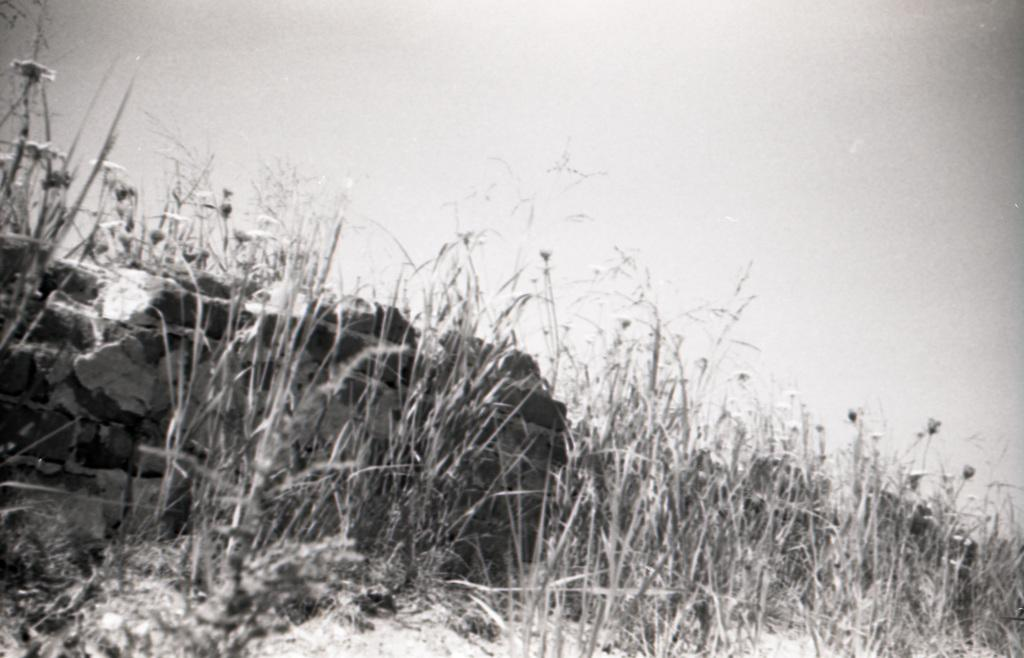What type of plants can be seen in the image? There are plants with flowers in the image. What is the condition of the sky in the image? The sky is cloudy in the image. What type of brass instrument is being played in the image? There is no brass instrument present in the image; it only features plants with flowers and a cloudy sky. 